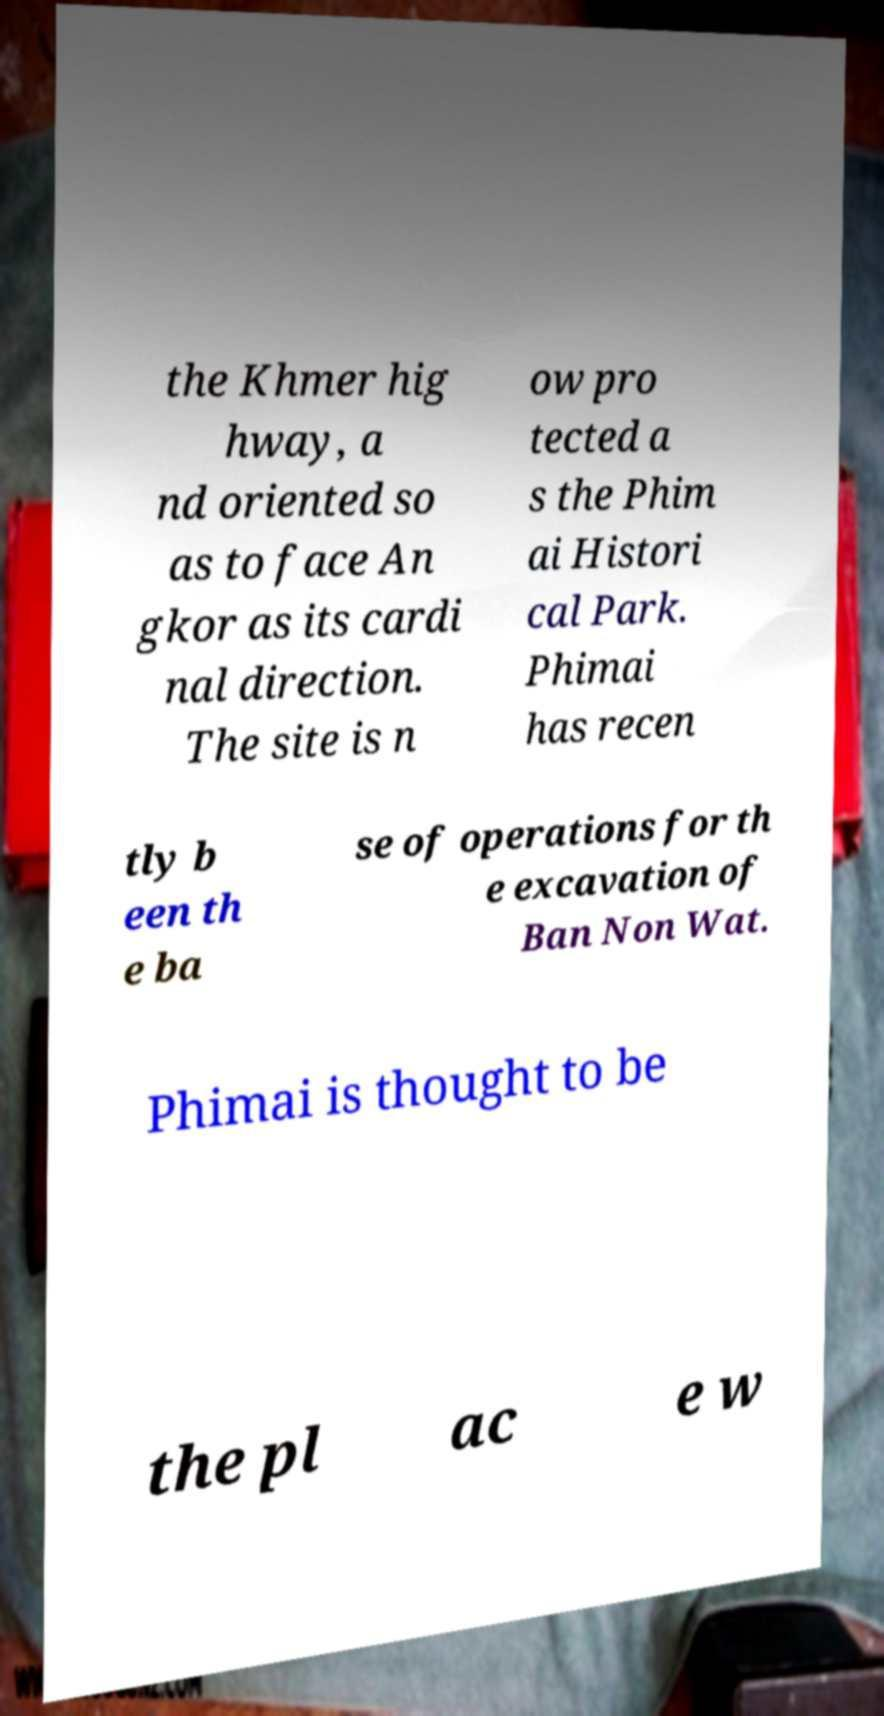Can you read and provide the text displayed in the image?This photo seems to have some interesting text. Can you extract and type it out for me? the Khmer hig hway, a nd oriented so as to face An gkor as its cardi nal direction. The site is n ow pro tected a s the Phim ai Histori cal Park. Phimai has recen tly b een th e ba se of operations for th e excavation of Ban Non Wat. Phimai is thought to be the pl ac e w 